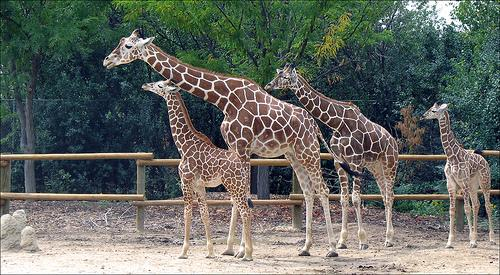Highlight the features and positioning of the tallest giraffe in the image. The tallest giraffe in the group has distinct head, neck, and tail features, and is positioned near a small giraffe, with spots and horns on its body. Mention a few key details about the baby giraffe(s) and their location within the image. One baby giraffe is looking up, in front under mother, while another is looking forward, positioned on the far right, and one more is in the back. Describe the baby giraffe's interaction with its parent in the image scene. A baby giraffe is looking up and appears to be near its parent, which is the tallest giraffe in the group, with a visible head, neck, and tail. Give a brief, general overview of the image's entire scene. The scene captures four giraffes in a zoo pen with wooden fencing, surrounded by an assortment of trees, rocks, and tree branches, featuring baby giraffes near their parents. What does the image primarily feature? Mention a few important objects and their positioning. The image features a group of four giraffes, with heads at various positions, baby giraffe looking up and forward, a fence made from wooden poles, and a dirt-covered ground of the giraffe pen. Briefly mention the main elements found in the image and their characteristics. In the image, there are giraffes with distinct features like heads, necks, legs, and brown spots, a wooden fence, rocks clustered on the ground, trees, and dirt-covered ground in the pen. Write a short description of the scene captured in the image. The image displays four giraffes at the zoo, interacting near a wooden fence, amidst rocks, tree branches, and dying yellow leaves, with green trees visible behind the fence. Enumerate the main characteristics of the giraffe and pen setting present in the image. The image features giraffes with heads, faces, necks, legs, and feet, a baby giraffe near parent, wooden fencing around the area, and ground without grass in the giraffe area. Outline the key features of the giraffe pen as portrayed in the image. The giraffe pen in the image includes wooden fencing, dirt-covered ground without grass, trees, rocks clustered on the ground, and tree branches lying around. Provide a summary of the landscape and surroundings in the image. The image showcases trees behind the giraffes, a wooden split rail fence by them, dirt-covered ground in the pen, large rocks near the fence, and green trees on the other side. 